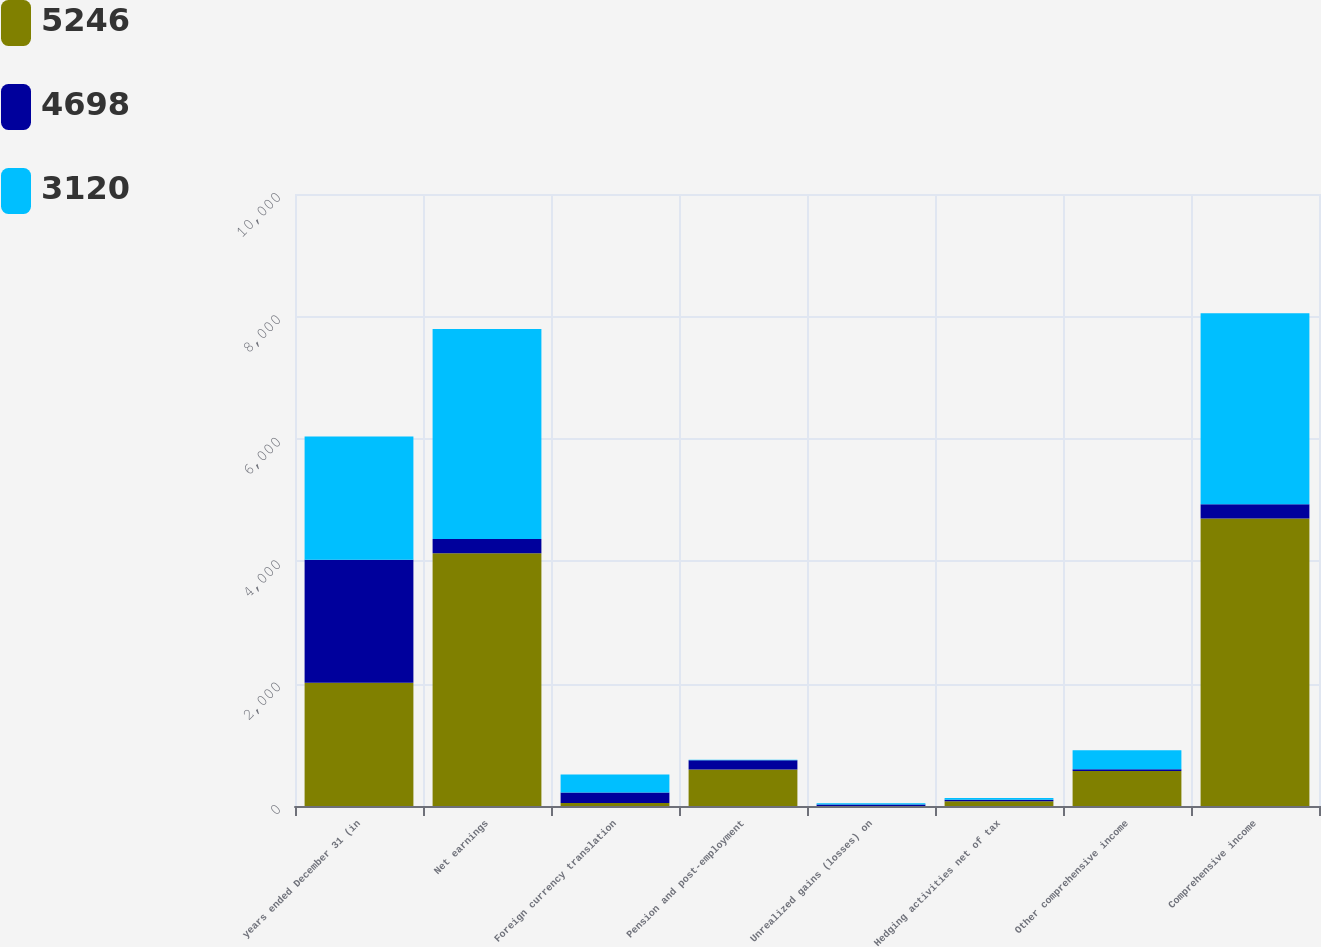Convert chart. <chart><loc_0><loc_0><loc_500><loc_500><stacked_bar_chart><ecel><fcel>years ended December 31 (in<fcel>Net earnings<fcel>Foreign currency translation<fcel>Pension and post-employment<fcel>Unrealized gains (losses) on<fcel>Hedging activities net of tax<fcel>Other comprehensive income<fcel>Comprehensive income<nl><fcel>5246<fcel>2013<fcel>4128<fcel>48<fcel>598<fcel>1<fcel>77<fcel>570<fcel>4698<nl><fcel>4698<fcel>2012<fcel>234<fcel>173<fcel>150<fcel>25<fcel>27<fcel>29<fcel>234<nl><fcel>3120<fcel>2011<fcel>3433<fcel>295<fcel>7<fcel>17<fcel>28<fcel>313<fcel>3120<nl></chart> 